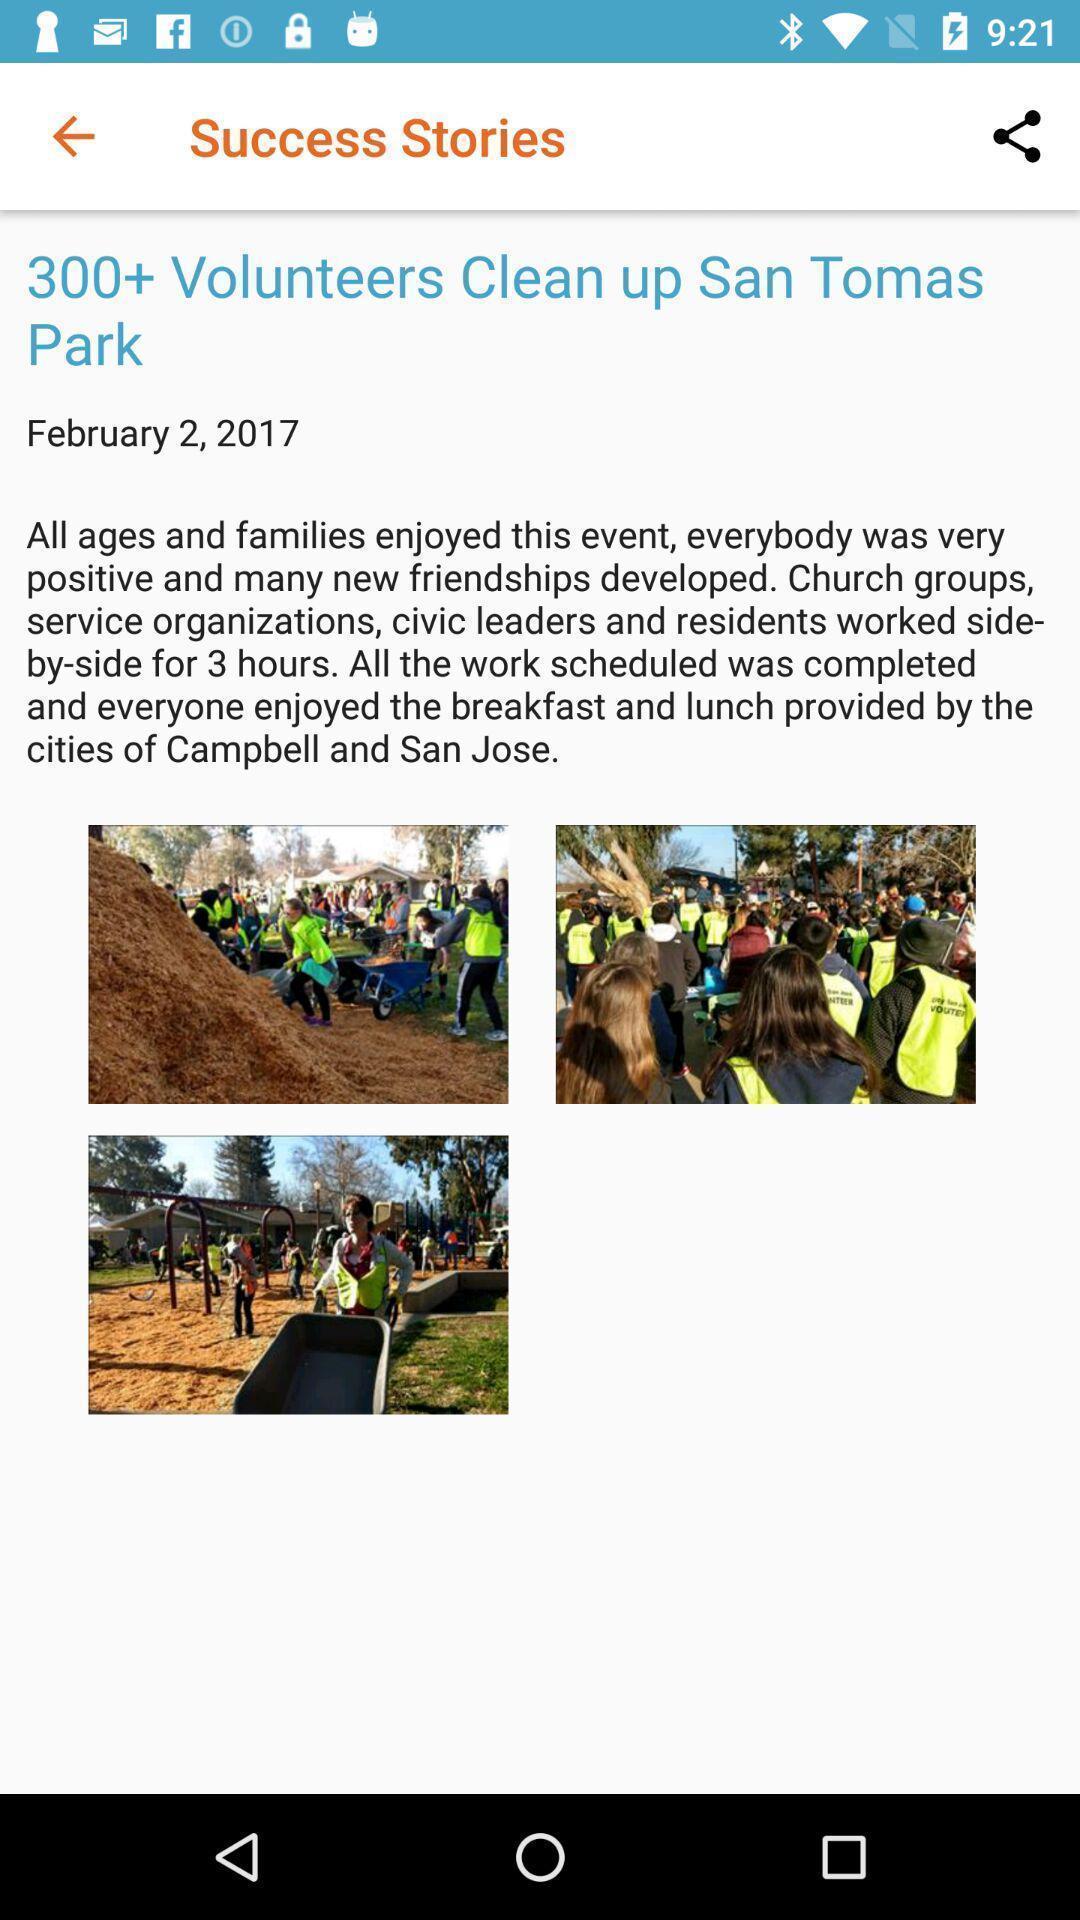Provide a detailed account of this screenshot. Story of success in social app. 